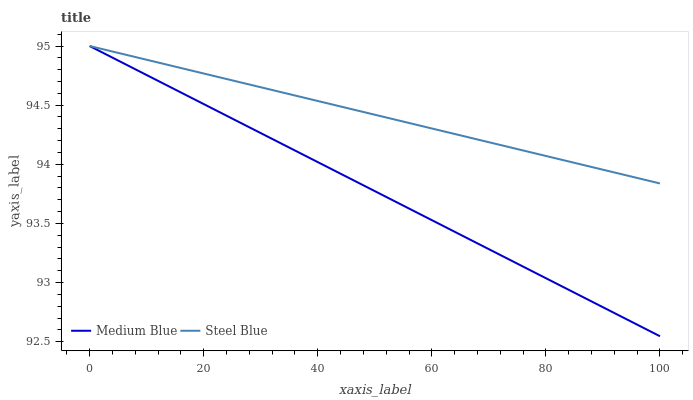Does Medium Blue have the minimum area under the curve?
Answer yes or no. Yes. Does Steel Blue have the maximum area under the curve?
Answer yes or no. Yes. Does Steel Blue have the minimum area under the curve?
Answer yes or no. No. Is Medium Blue the smoothest?
Answer yes or no. Yes. Is Steel Blue the roughest?
Answer yes or no. Yes. Is Steel Blue the smoothest?
Answer yes or no. No. Does Medium Blue have the lowest value?
Answer yes or no. Yes. Does Steel Blue have the lowest value?
Answer yes or no. No. Does Steel Blue have the highest value?
Answer yes or no. Yes. Does Steel Blue intersect Medium Blue?
Answer yes or no. Yes. Is Steel Blue less than Medium Blue?
Answer yes or no. No. Is Steel Blue greater than Medium Blue?
Answer yes or no. No. 